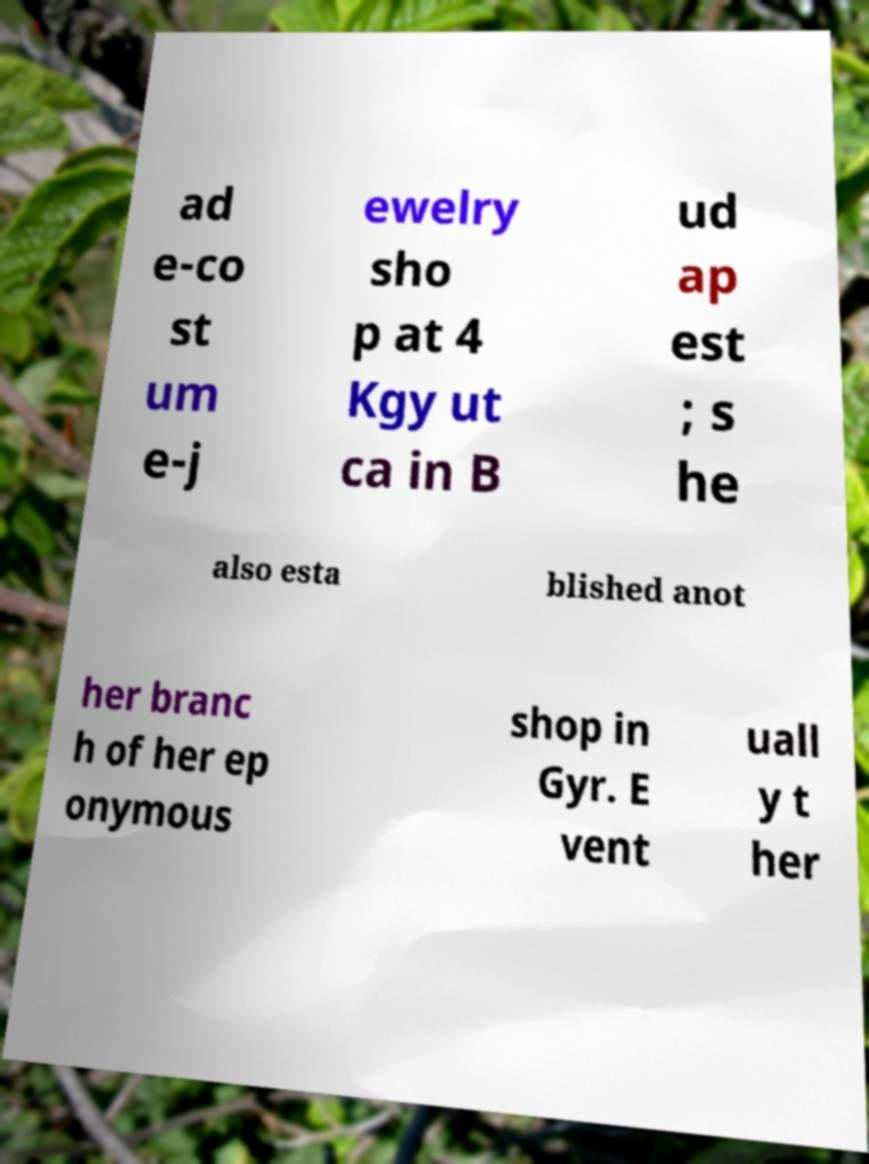I need the written content from this picture converted into text. Can you do that? ad e-co st um e-j ewelry sho p at 4 Kgy ut ca in B ud ap est ; s he also esta blished anot her branc h of her ep onymous shop in Gyr. E vent uall y t her 